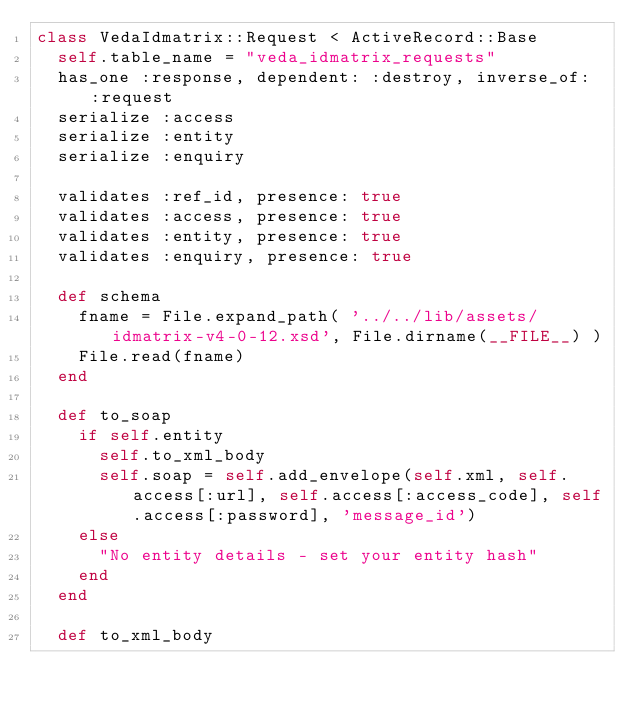Convert code to text. <code><loc_0><loc_0><loc_500><loc_500><_Ruby_>class VedaIdmatrix::Request < ActiveRecord::Base
  self.table_name = "veda_idmatrix_requests"
  has_one :response, dependent: :destroy, inverse_of: :request
  serialize :access
  serialize :entity
  serialize :enquiry

  validates :ref_id, presence: true
  validates :access, presence: true
  validates :entity, presence: true
  validates :enquiry, presence: true

  def schema
    fname = File.expand_path( '../../lib/assets/idmatrix-v4-0-12.xsd', File.dirname(__FILE__) )
    File.read(fname)
  end

  def to_soap
    if self.entity
      self.to_xml_body
      self.soap = self.add_envelope(self.xml, self.access[:url], self.access[:access_code], self.access[:password], 'message_id')
    else
      "No entity details - set your entity hash"
    end
  end

  def to_xml_body</code> 